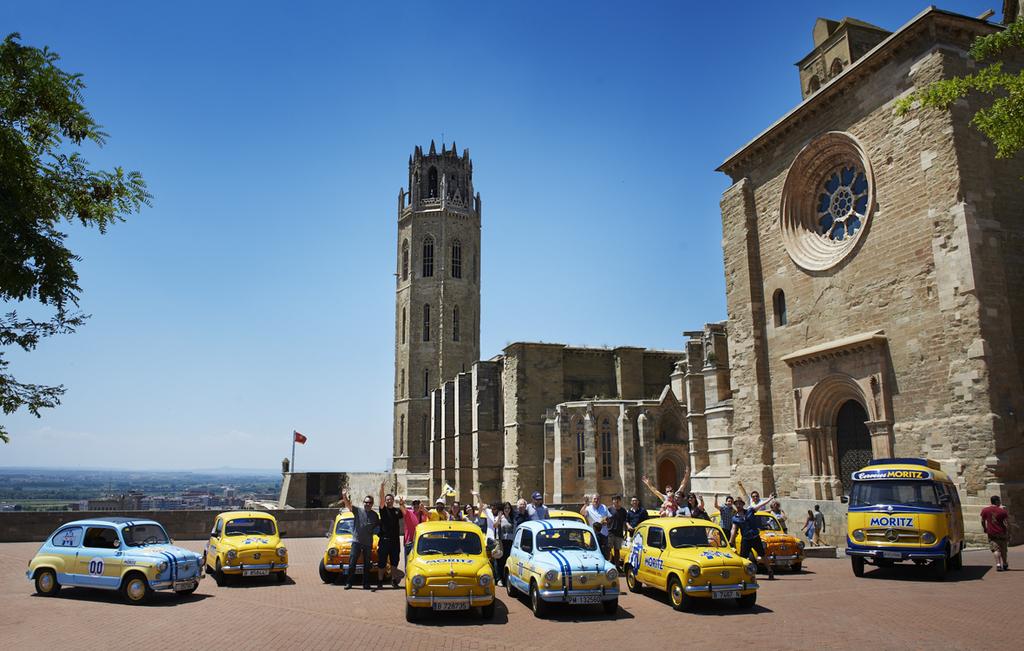What is the name of the bus on the right?
Your response must be concise. Moritz. What color is most of these vehicles?
Offer a very short reply. Answering does not require reading text in the image. 